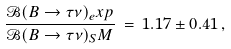Convert formula to latex. <formula><loc_0><loc_0><loc_500><loc_500>\frac { \mathcal { B } ( B \rightarrow \tau \nu ) _ { e } x p } { \mathcal { B } ( B \rightarrow \tau \nu ) _ { S } M } \, = \, 1 . 1 7 \pm 0 . 4 1 \, ,</formula> 